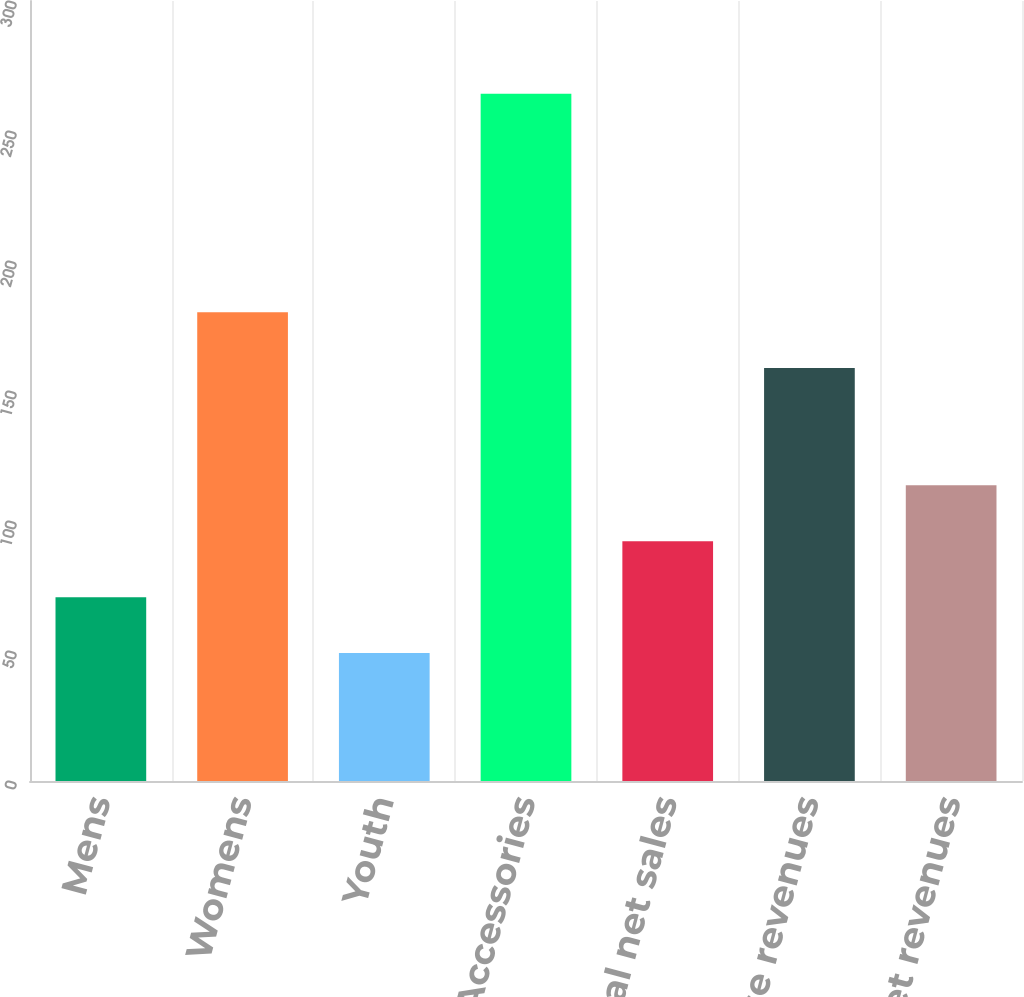Convert chart to OTSL. <chart><loc_0><loc_0><loc_500><loc_500><bar_chart><fcel>Mens<fcel>Womens<fcel>Youth<fcel>Accessories<fcel>Total net sales<fcel>License revenues<fcel>Total net revenues<nl><fcel>70.71<fcel>180.31<fcel>49.2<fcel>264.3<fcel>92.22<fcel>158.8<fcel>113.73<nl></chart> 